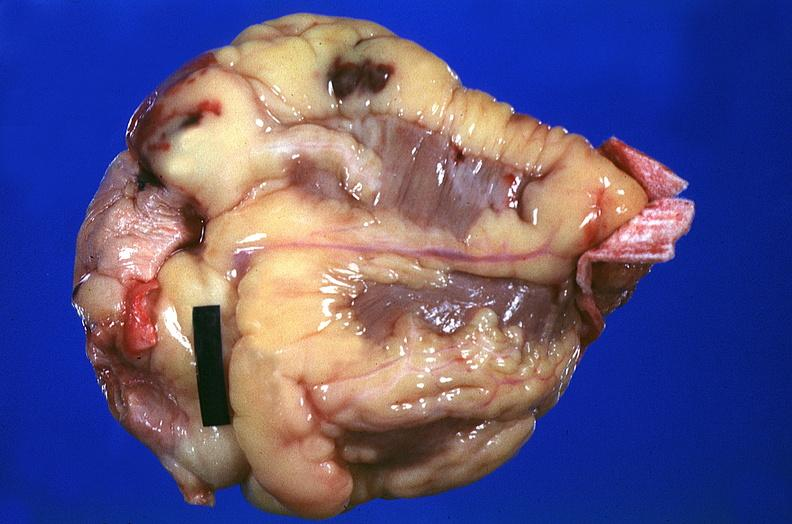does retroperitoneal leiomyosarcoma show heart, myocardial infarction, surgery to repair interventricular septum rupture?
Answer the question using a single word or phrase. No 